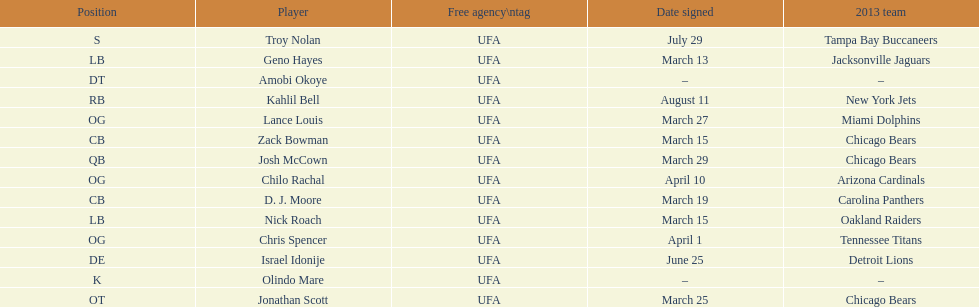Geno hayes and nick roach both played which position? LB. 